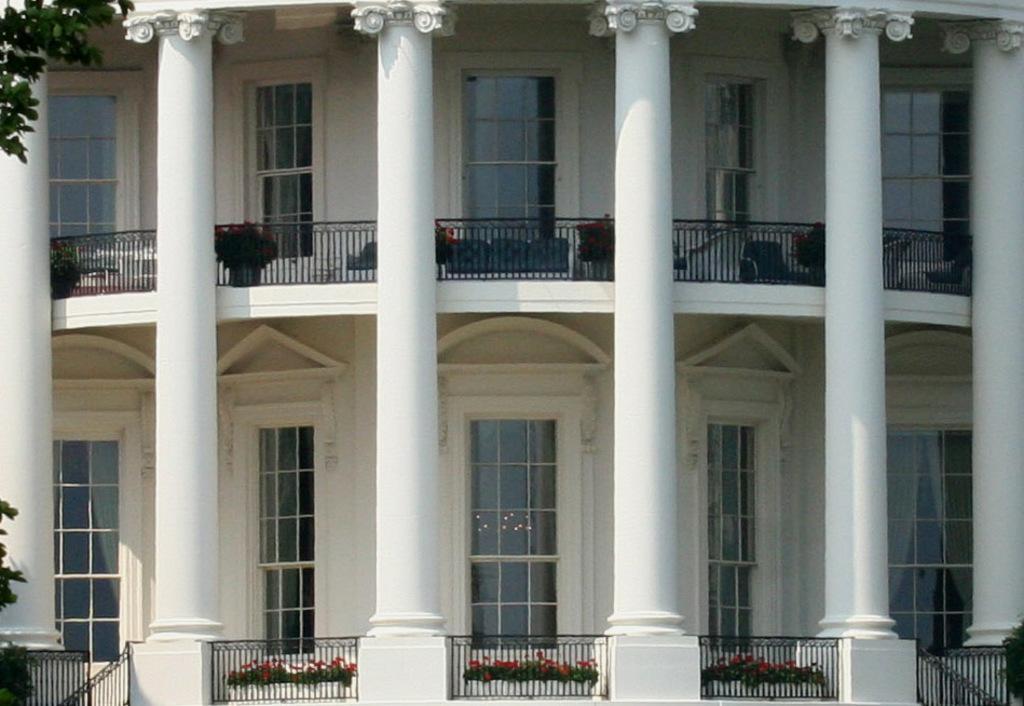Can you describe this image briefly? In this picture I can see a building and few plants in the pots and I can see tree branches with leaves. 